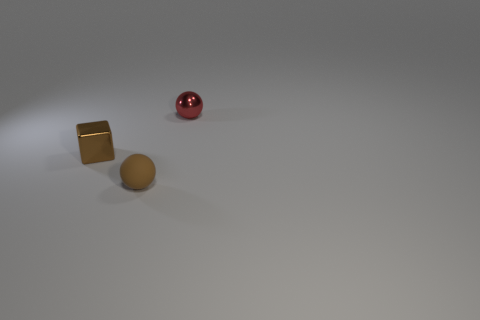Is there anything else that is the same material as the tiny brown ball?
Offer a terse response. No. Does the tiny thing that is in front of the brown block have the same material as the ball behind the matte object?
Give a very brief answer. No. Is there a red metal object that has the same shape as the brown matte thing?
Make the answer very short. Yes. What number of things are shiny objects that are in front of the red shiny sphere or balls?
Your answer should be compact. 3. Are there more red objects on the left side of the red metallic object than red metal objects in front of the metallic block?
Offer a terse response. No. How many shiny things are either tiny red spheres or tiny brown objects?
Make the answer very short. 2. There is another tiny object that is the same color as the rubber thing; what is its material?
Keep it short and to the point. Metal. Is the number of metallic objects that are in front of the small matte object less than the number of small brown rubber spheres behind the red object?
Make the answer very short. No. How many objects are big red matte blocks or tiny objects that are behind the brown matte sphere?
Keep it short and to the point. 2. What material is the brown sphere that is the same size as the cube?
Your answer should be very brief. Rubber. 